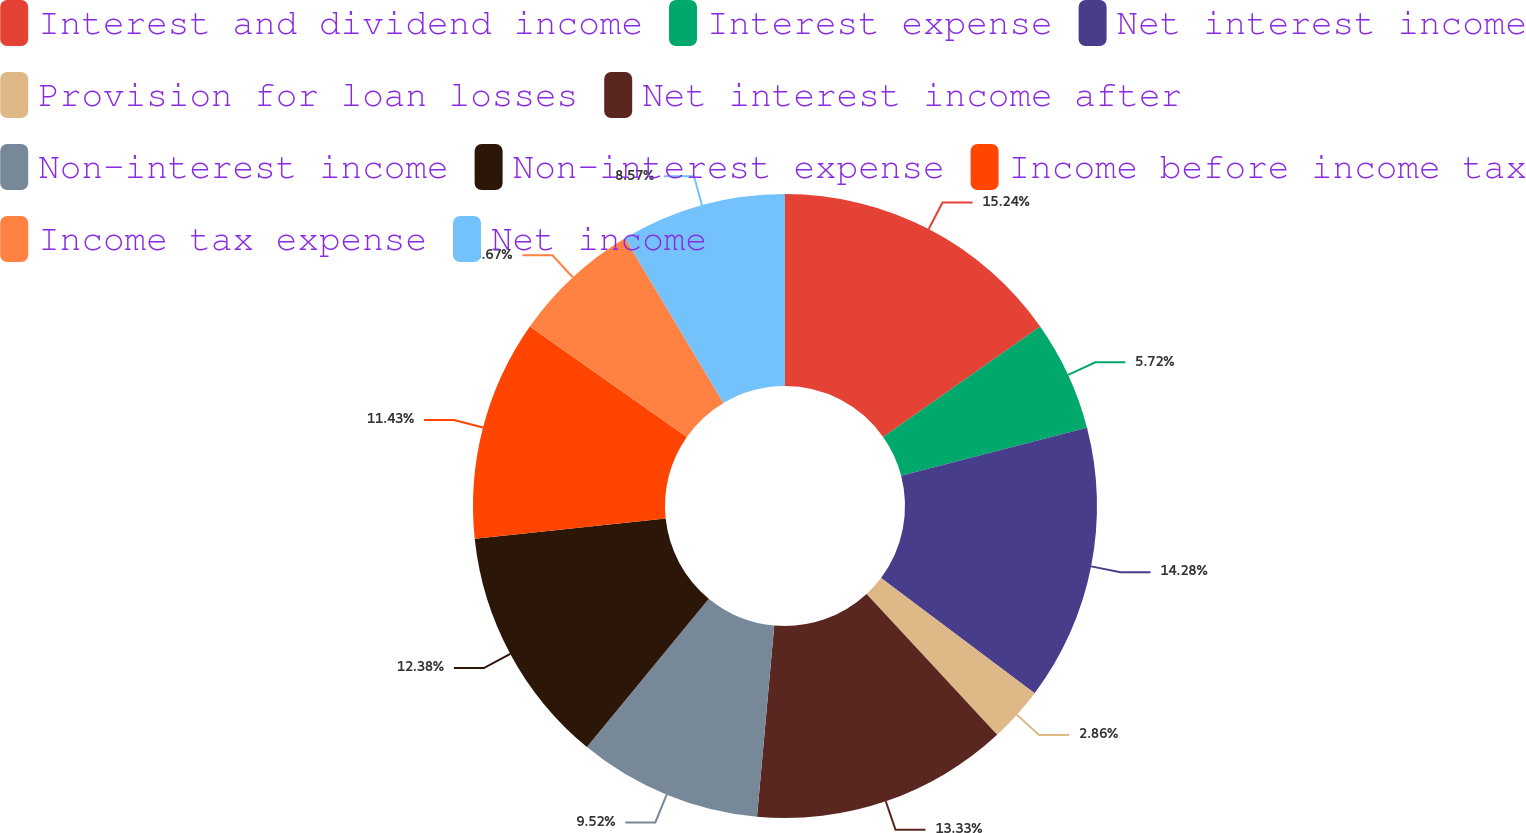Convert chart to OTSL. <chart><loc_0><loc_0><loc_500><loc_500><pie_chart><fcel>Interest and dividend income<fcel>Interest expense<fcel>Net interest income<fcel>Provision for loan losses<fcel>Net interest income after<fcel>Non-interest income<fcel>Non-interest expense<fcel>Income before income tax<fcel>Income tax expense<fcel>Net income<nl><fcel>15.24%<fcel>5.72%<fcel>14.28%<fcel>2.86%<fcel>13.33%<fcel>9.52%<fcel>12.38%<fcel>11.43%<fcel>6.67%<fcel>8.57%<nl></chart> 